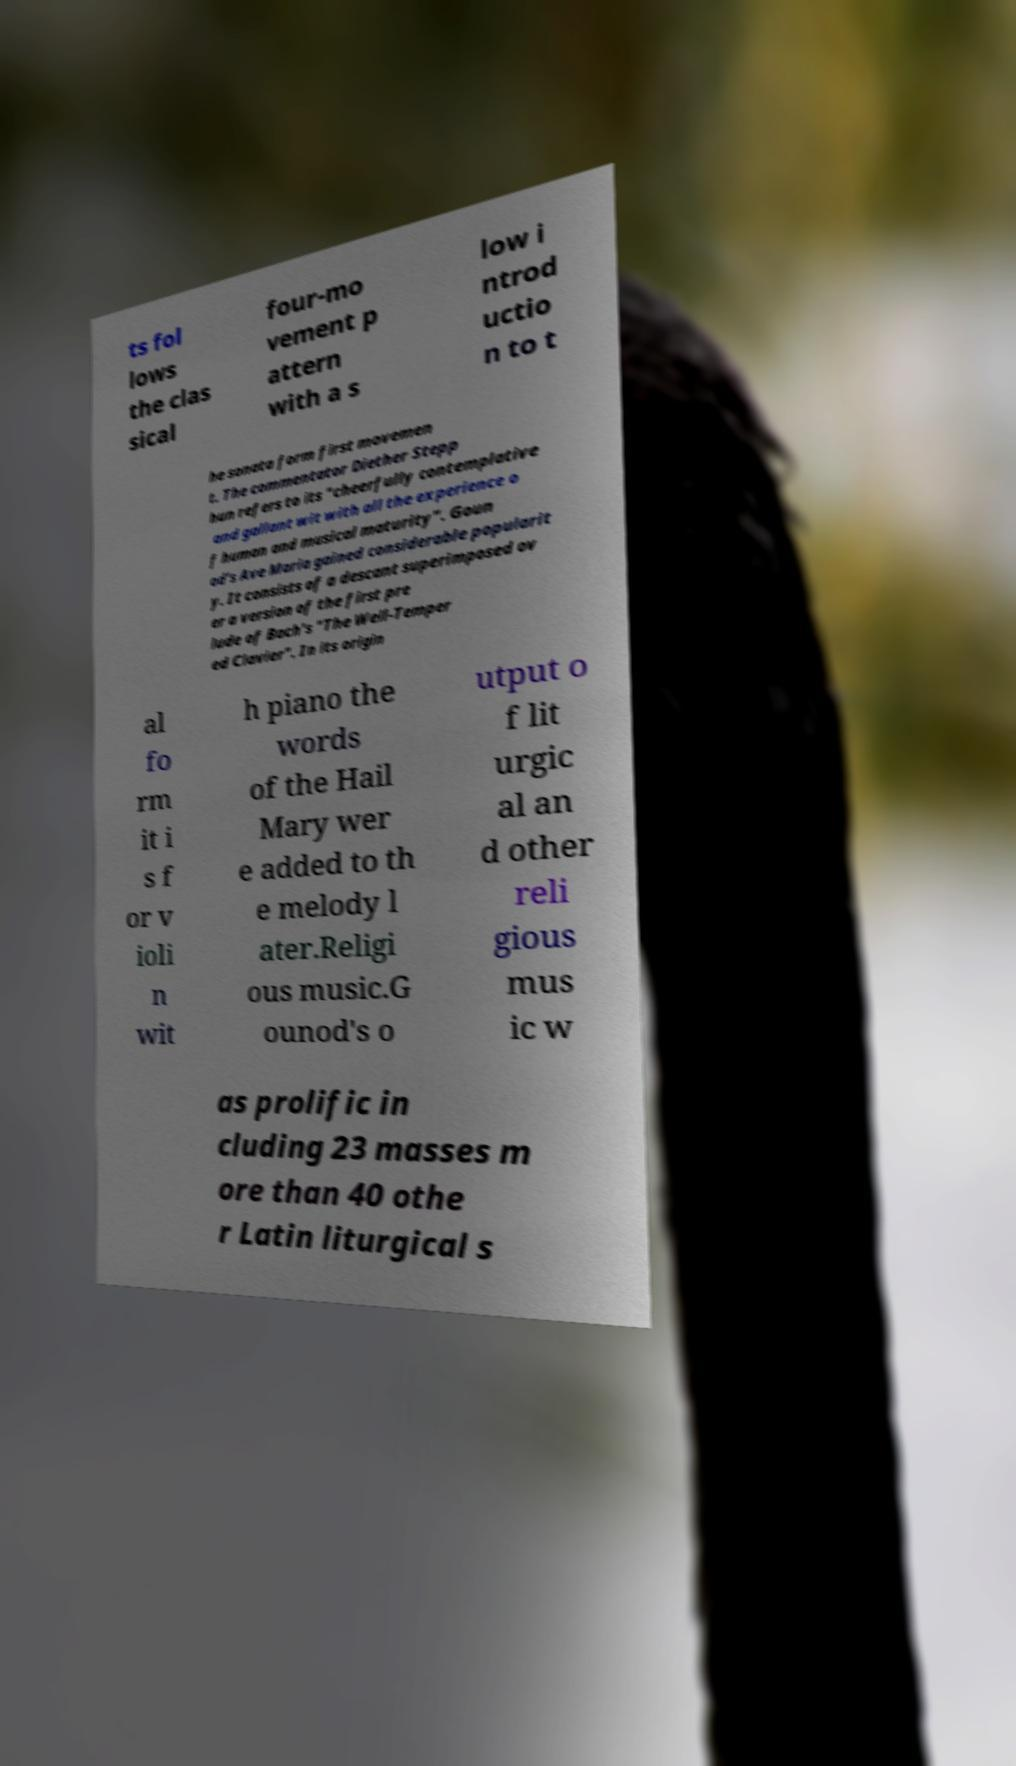Can you read and provide the text displayed in the image?This photo seems to have some interesting text. Can you extract and type it out for me? ts fol lows the clas sical four-mo vement p attern with a s low i ntrod uctio n to t he sonata form first movemen t. The commentator Diether Stepp hun refers to its "cheerfully contemplative and gallant wit with all the experience o f human and musical maturity". Goun od's Ave Maria gained considerable popularit y. It consists of a descant superimposed ov er a version of the first pre lude of Bach's "The Well-Temper ed Clavier". In its origin al fo rm it i s f or v ioli n wit h piano the words of the Hail Mary wer e added to th e melody l ater.Religi ous music.G ounod's o utput o f lit urgic al an d other reli gious mus ic w as prolific in cluding 23 masses m ore than 40 othe r Latin liturgical s 